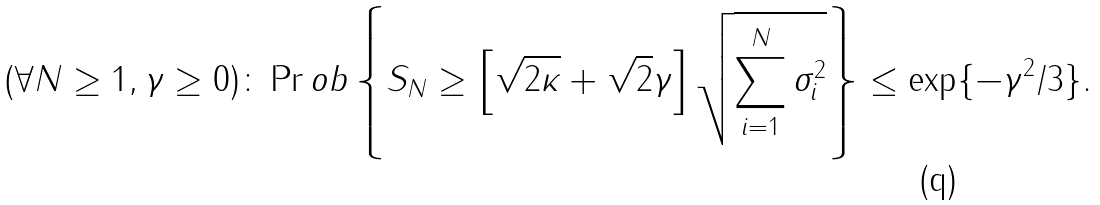Convert formula to latex. <formula><loc_0><loc_0><loc_500><loc_500>( \forall N \geq 1 , \gamma \geq 0 ) \colon \Pr o b \left \{ \| S _ { N } \| \geq \left [ \sqrt { 2 \kappa } + \sqrt { 2 } \gamma \right ] \sqrt { \sum _ { i = 1 } ^ { N } \sigma _ { i } ^ { 2 } } \right \} \leq \exp \{ - \gamma ^ { 2 } / 3 \} .</formula> 